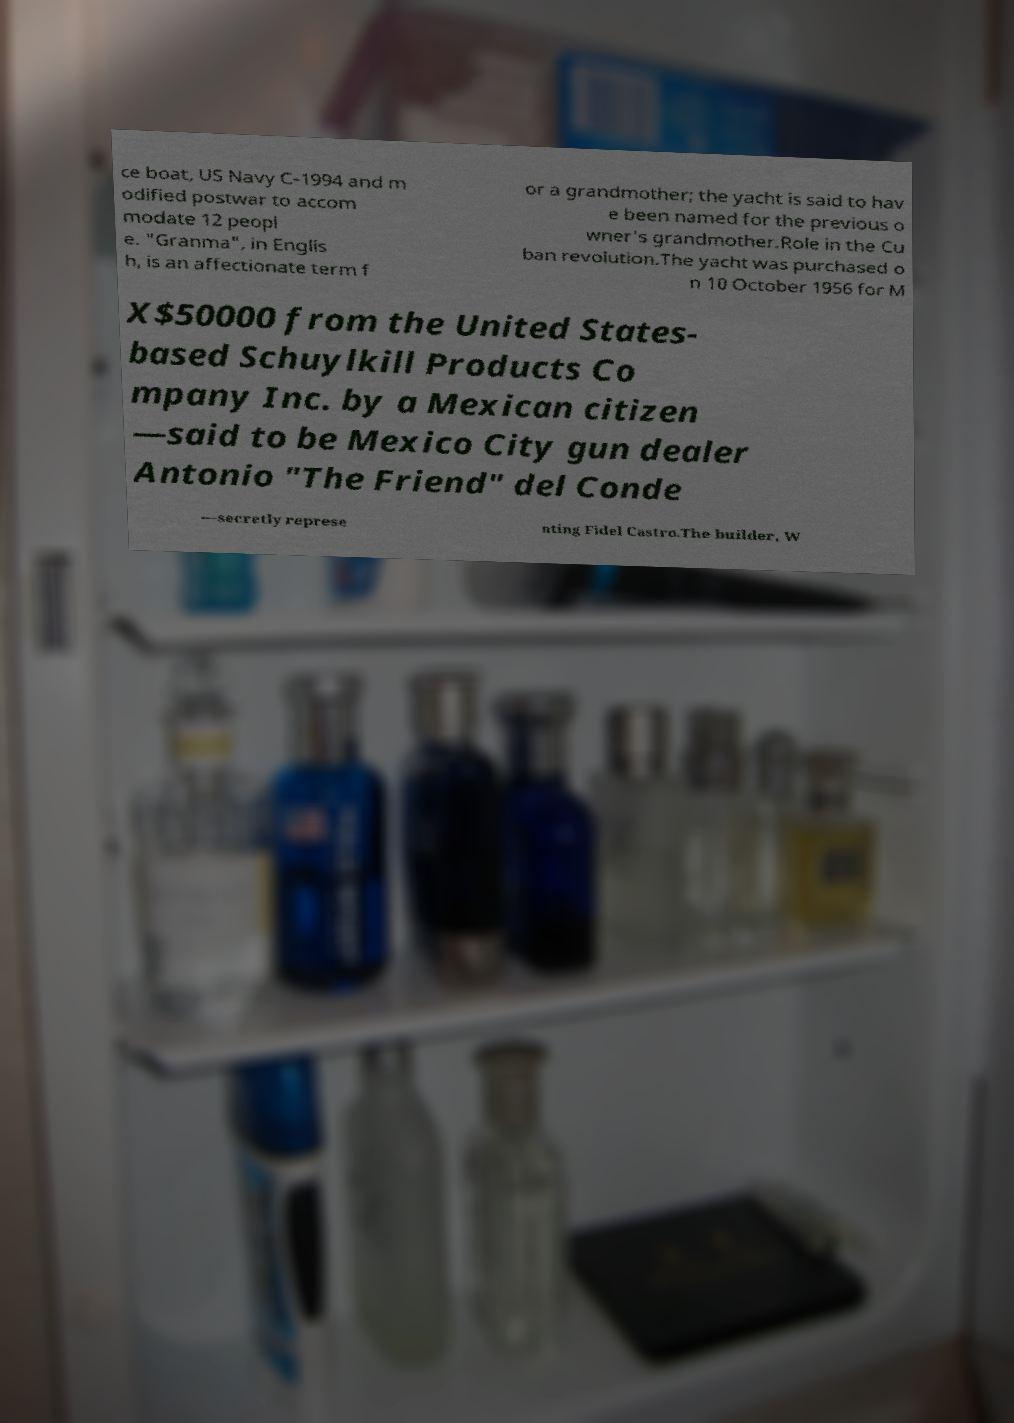Can you accurately transcribe the text from the provided image for me? ce boat, US Navy C-1994 and m odified postwar to accom modate 12 peopl e. "Granma", in Englis h, is an affectionate term f or a grandmother; the yacht is said to hav e been named for the previous o wner's grandmother.Role in the Cu ban revolution.The yacht was purchased o n 10 October 1956 for M X$50000 from the United States- based Schuylkill Products Co mpany Inc. by a Mexican citizen —said to be Mexico City gun dealer Antonio "The Friend" del Conde —secretly represe nting Fidel Castro.The builder, W 